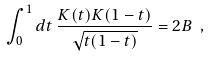Convert formula to latex. <formula><loc_0><loc_0><loc_500><loc_500>\int ^ { 1 } _ { 0 } d t \, \frac { K ( t ) K ( 1 - t ) } { \sqrt { t ( 1 - t ) } } = 2 B \ ,</formula> 